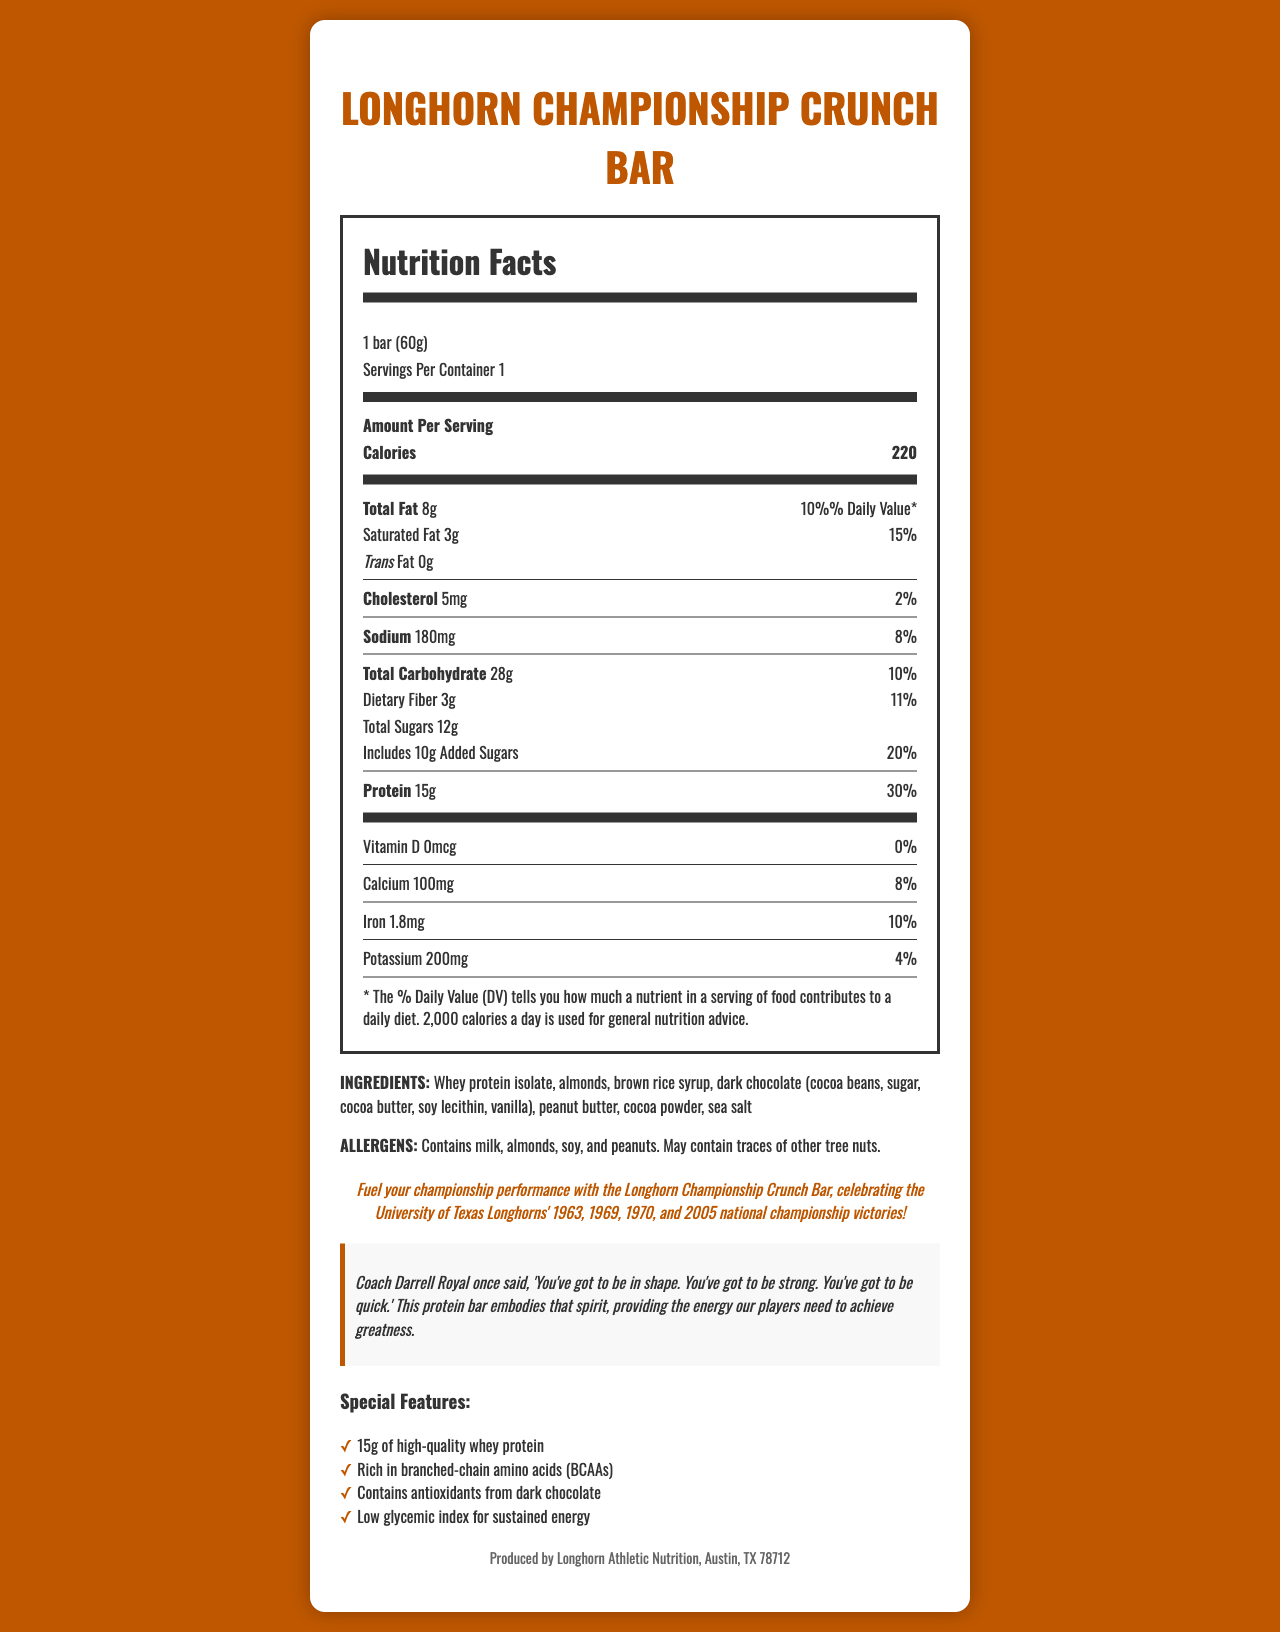what is the serving size of the Longhorn Championship Crunch Bar? The serving size is listed at the beginning of the Nutrition Facts Label as "1 bar (60g)."
Answer: 1 bar (60g) How many calories are in one serving of the Longhorn Championship Crunch Bar? The number of calories per serving is displayed prominently near the top of the Nutrition Facts Label with the value 220.
Answer: 220 What is the percentage of Daily Value for Total Fat? The percentage of Daily Value for Total Fat is indicated next to its amount, which is 10%.
Answer: 10% How much protein does the Longhorn Championship Crunch Bar provide? The amount of protein is listed under the Protein section of the Nutrition Facts Label as 15g.
Answer: 15g Does the protein bar contain any trans fat? The amount of trans fat is listed as 0g in the Nutrition Facts Label, indicating there is no trans fat.
Answer: No How much calcium does the Longhorn Championship Crunch Bar contain? A. 50mg B. 100mg C. 150mg D. 200mg The Nutrition Facts Label states that the calcium content is 100mg.
Answer: B. 100mg What are the allergens present in the Longhorn Championship Crunch Bar? A. Milk B. Almonds C. Peanuts D. All of the above The allergen information indicates the bar contains milk, almonds, soy, and peanuts.
Answer: D. All of the above What is the main ingredient providing the protein in the bar? The ingredients section lists whey protein isolate as the first ingredient, indicating it is a primary source of protein in the bar.
Answer: Whey protein isolate Does the Longhorn Championship Crunch Bar contain any dietary fiber? The dietary fiber amount is listed as 3g in the Nutrition Facts Label.
Answer: Yes Explain the special features of the Longhorn Championship Crunch Bar. The special features section provides details on the unique aspects of the bar, including protein content, BCAA richness, antioxidant content, and glycemic index.
Answer: The bar has 15g of high-quality whey protein, is rich in branched-chain amino acids (BCAAs), contains antioxidants from dark chocolate, and has a low glycemic index for sustained energy. Is there any cholesterol in the Longhorn Championship Crunch Bar? The Nutrition Facts Label lists 5mg of cholesterol.
Answer: Yes Describe the purpose and significance of the Longhorn Championship Crunch Bar according to the document. The document combines nutritional data with a commemorative angle, using high protein content, special features like BCAAs and antioxidants, and a quote from Coach Royal to highlight both the product's utility and its symbolic significance.
Answer: The Longhorn Championship Crunch Bar is designed to fuel athletic performance and commemorate the University of Texas Longhorns' national championship victories. It provides substantial protein and other beneficial nutrients to help athletes achieve greatness, in line with Coach Darrell Royal's emphasis on strength, quickness, and good shape. What is the percentage of Daily Value for saturated fat in the bar? The percentage of Daily Value for saturated fat is shown as 15% next to the amount of saturated fat.
Answer: 15% What is the manufacturer location of the Longhorn Championship Crunch Bar? The manufacturer info at the bottom of the document lists Austin, TX 78712 as the location.
Answer: Austin, TX 78712 What is the source of antioxidants in the bar? The document's special features mention that the bar contains antioxidants from dark chocolate.
Answer: Dark chocolate Does the bar contain Vitamin D? The Nutrition Facts Label lists the amount of Vitamin D as 0mcg, indicating there is no Vitamin D.
Answer: No Who is quoted in the document, and what is emphasized in the quote? The coach quote section cites Coach Darrell Royal, focusing on the importance of physical fitness attributes.
Answer: Coach Darrell Royal; the quote emphasizes being in shape, being strong, and being quick. What is the significance of Coach Darrell Royal's quote in relation to the product? Coach Darrell Royal's quote underscores the importance of physical fitness, complementing the nutritional benefits of the protein bar designed to support athletic prowess.
Answer: The quote emphasizes the attributes of being in shape, strong, and quick, reflecting the purpose of the protein bar to enhance athletic performance. How many added sugars are in the Longhorn Championship Crunch Bar? The Nutrition Facts Label shows that there are 10g of added sugars.
Answer: 10g Why was the Longhorn Championship Crunch Bar created? The brand statement and context of the document indicate that the bar was created to celebrate the Longhorns' championship history while providing substantive nutritional benefits for athletes.
Answer: To commemorate the University of Texas Longhorns' national championship victories and to provide nutritional support for athletic performance. Does the bar contain potassium? The Nutrition Facts Label lists potassium content, indicating the bar contains potassium.
Answer: Yes How much sodium is in the Longhorn Championship Crunch Bar? The Nutrition Facts Label specifies that the bar contains 180mg of sodium.
Answer: 180mg What is the glycemic index characteristic of the bar? The special features section highlights that the bar has a low glycemic index for sustained energy.
Answer: Low glycemic index How many servings are in one container of the Longhorn Championship Crunch Bar? The servings per container is indicated as 1 in the Nutrition Facts Label.
Answer: 1 Can the origin of the ingredients be determined from the document? The document does not provide detailed information about the origin of the ingredients.
Answer: Not enough information What is the target audience for the Longhorn Championship Crunch Bar? The product, with its high protein and sports nutrition focus, along with the commemorative angle for Longhorns' national championships, targets both athletes and fans of the University of Texas Longhorns.
Answer: Athletes and Longhorns fans 